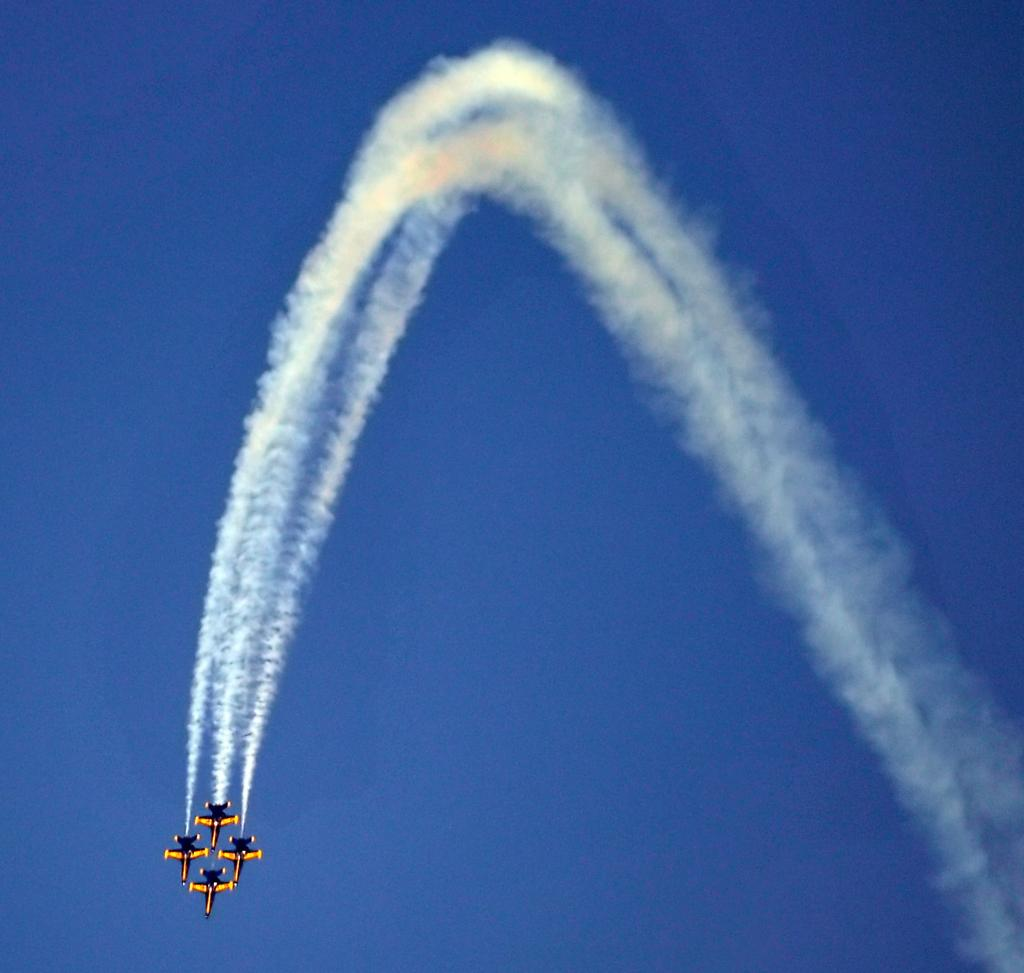What can be seen in the image that is not a solid object? There is smoke in the image. What type of vehicles are present in the image? There are airplanes in the image. What is visible in the background of the image? The sky is visible in the background of the image. What type of jeans are being worn by the airplanes in the image? There are no jeans present in the image, as airplanes do not wear clothing. 